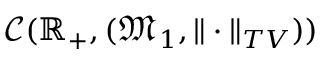Convert formula to latex. <formula><loc_0><loc_0><loc_500><loc_500>\mathcal { C } ( \mathbb { R } _ { + } , ( \mathfrak { M } _ { 1 } , \| \cdot \| _ { T V } ) )</formula> 